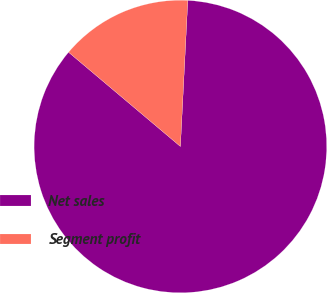Convert chart to OTSL. <chart><loc_0><loc_0><loc_500><loc_500><pie_chart><fcel>Net sales<fcel>Segment profit<nl><fcel>85.34%<fcel>14.66%<nl></chart> 